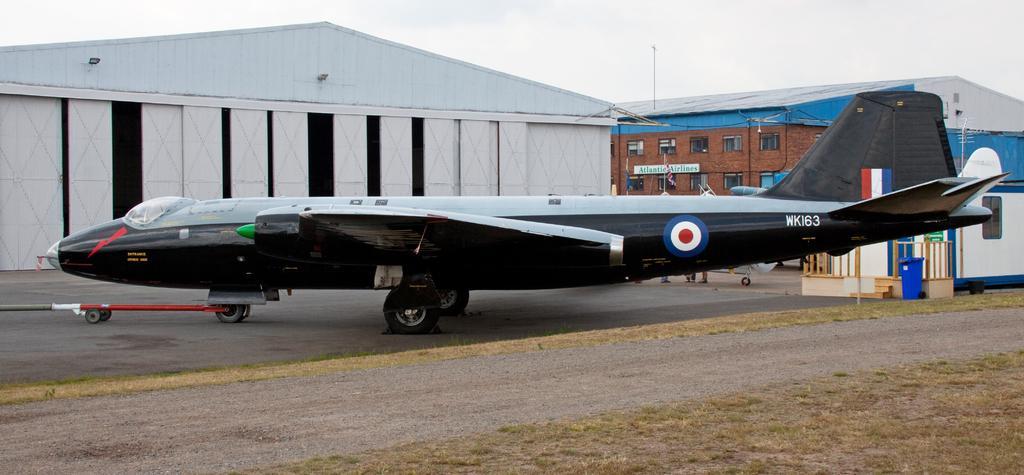Could you give a brief overview of what you see in this image? In this picture we can see an airplane in the front, in the background there are some buildings, at the bottom there is grass, we can see the sky at the top of the picture, there are windows of the building. 